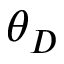Convert formula to latex. <formula><loc_0><loc_0><loc_500><loc_500>\theta _ { D }</formula> 